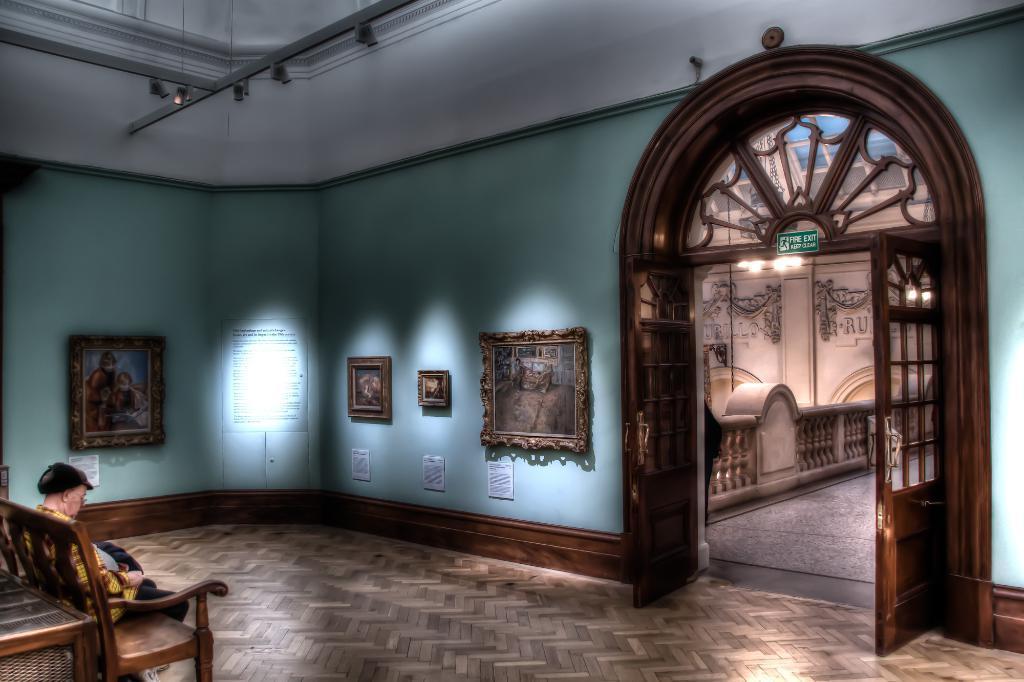Describe this image in one or two sentences. In this room on the left a person is sitting on the chair and there are frames on the wall. On the right there is a entry door and lights. 